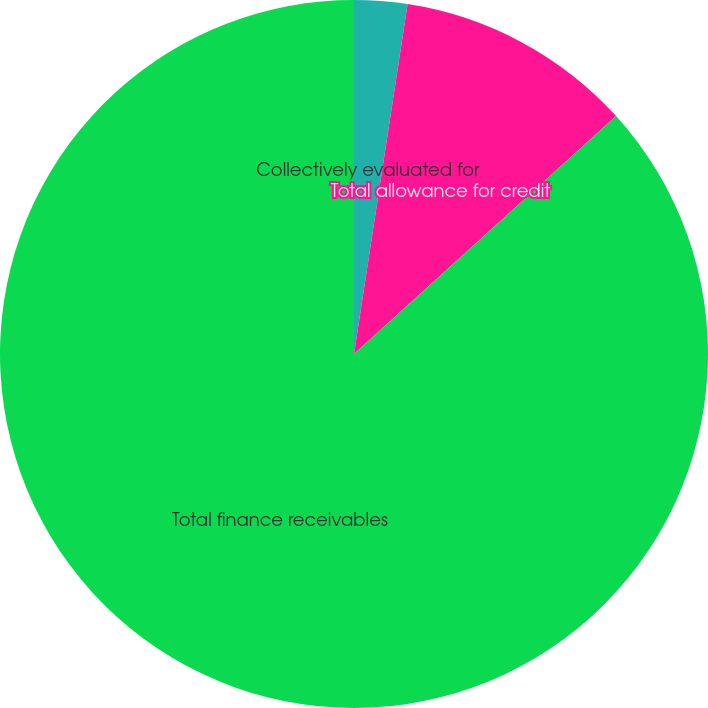Convert chart to OTSL. <chart><loc_0><loc_0><loc_500><loc_500><pie_chart><fcel>Collectively evaluated for<fcel>Total allowance for credit<fcel>Total finance receivables<nl><fcel>2.42%<fcel>10.85%<fcel>86.73%<nl></chart> 